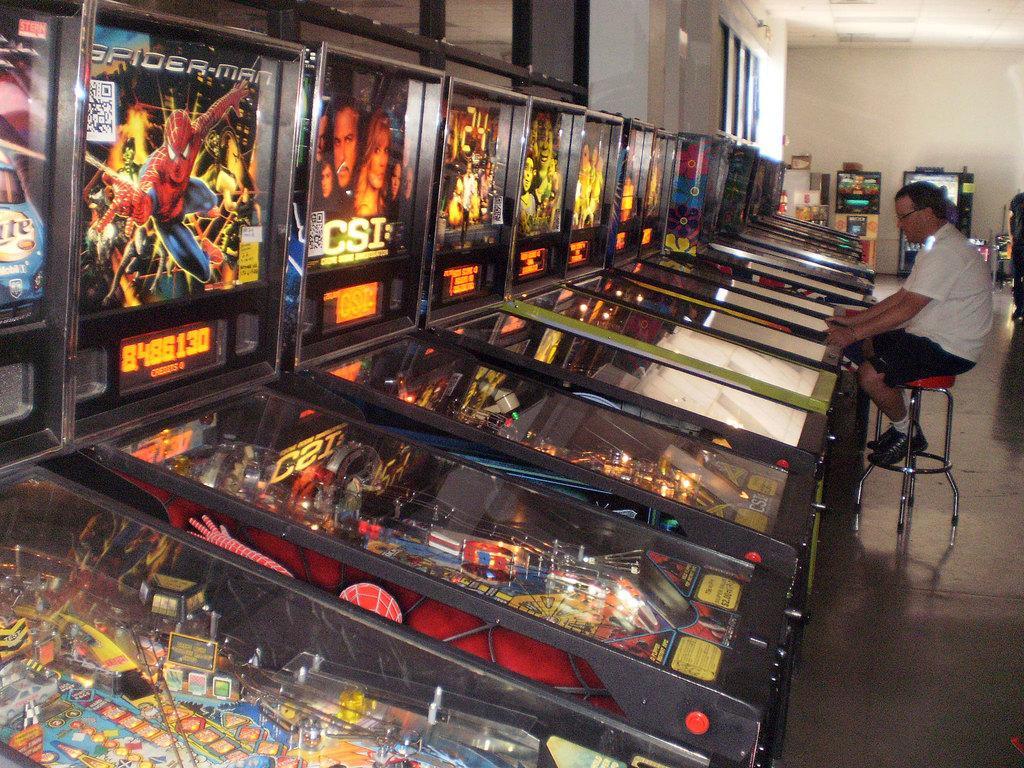Could you give a brief overview of what you see in this image? There are many pinball machines. On the right side there is a person wearing specs is sitting on a stool. In the back there is a wall. 